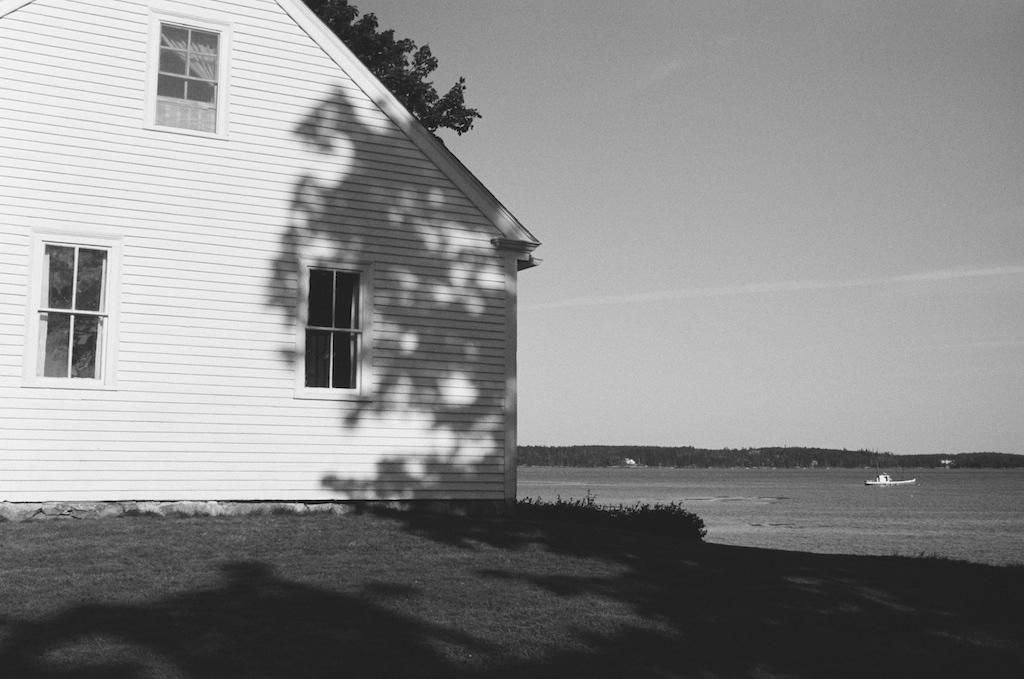Can you describe this image briefly? It is the black and white image in which there is a house on the left side. To the house there are three windows. At the bottom there is ground on which there is grass. On the right side there is water in which there is boat. 